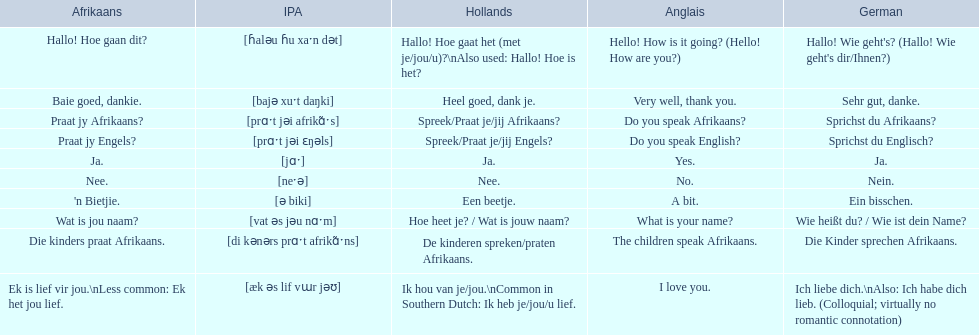How do you say 'i love you' in afrikaans? Ek is lief vir jou. 